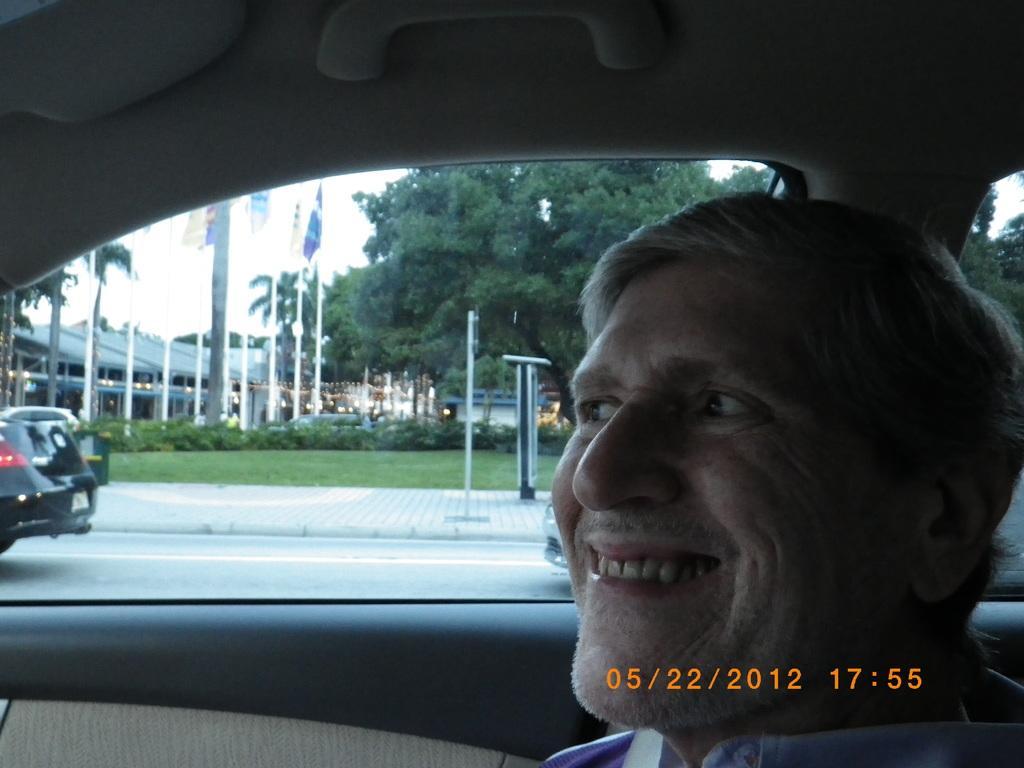Please provide a concise description of this image. The man who is sitting in the car is smiling. Beside him, we see cars moving on the road and beside that, we see buildings and flags and beside that, we see trees. 